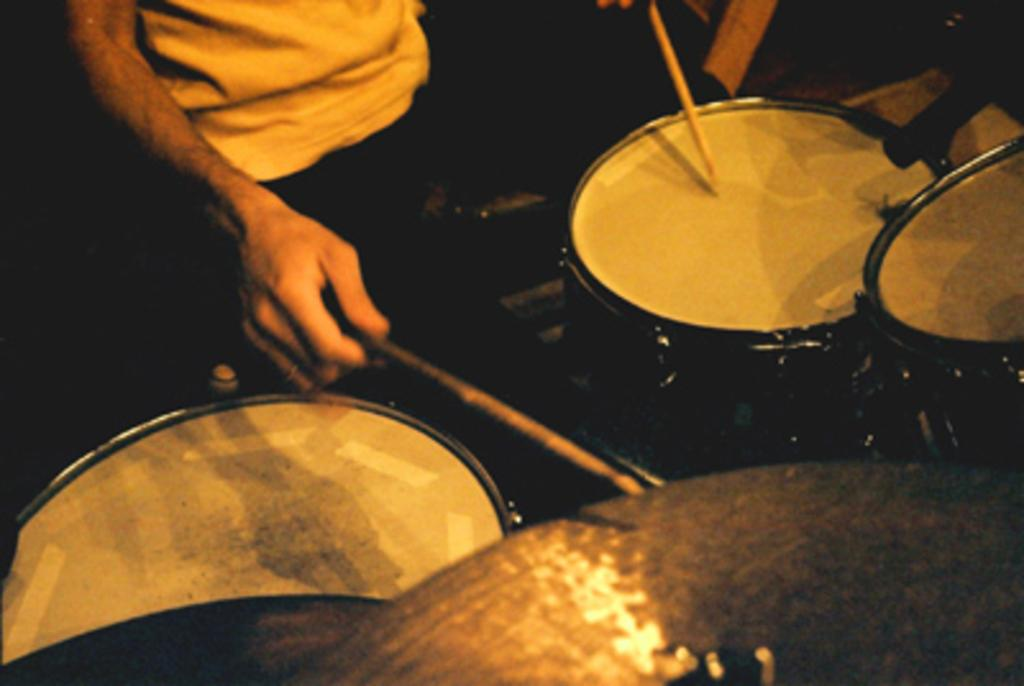What is the man in the image doing? The man is playing a drum set. What is the man using to play the drum set? The man is holding two sticks. What is the man wearing in the image? The man is wearing a yellow dress. How would you describe the lighting in the image? The image appears to be slightly dark. What type of pet can be seen in the image? There is no pet present in the image. What material is the drum set made of in the image? The provided facts do not mention the material of the drum set, so it cannot be determined from the image. 